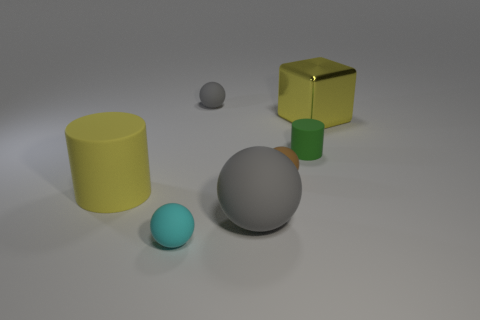Subtract all green spheres. Subtract all brown cylinders. How many spheres are left? 4 Add 3 cyan spheres. How many objects exist? 10 Subtract all cylinders. How many objects are left? 5 Add 4 yellow cubes. How many yellow cubes exist? 5 Subtract 1 cyan balls. How many objects are left? 6 Subtract all big yellow metallic objects. Subtract all tiny spheres. How many objects are left? 3 Add 3 big things. How many big things are left? 6 